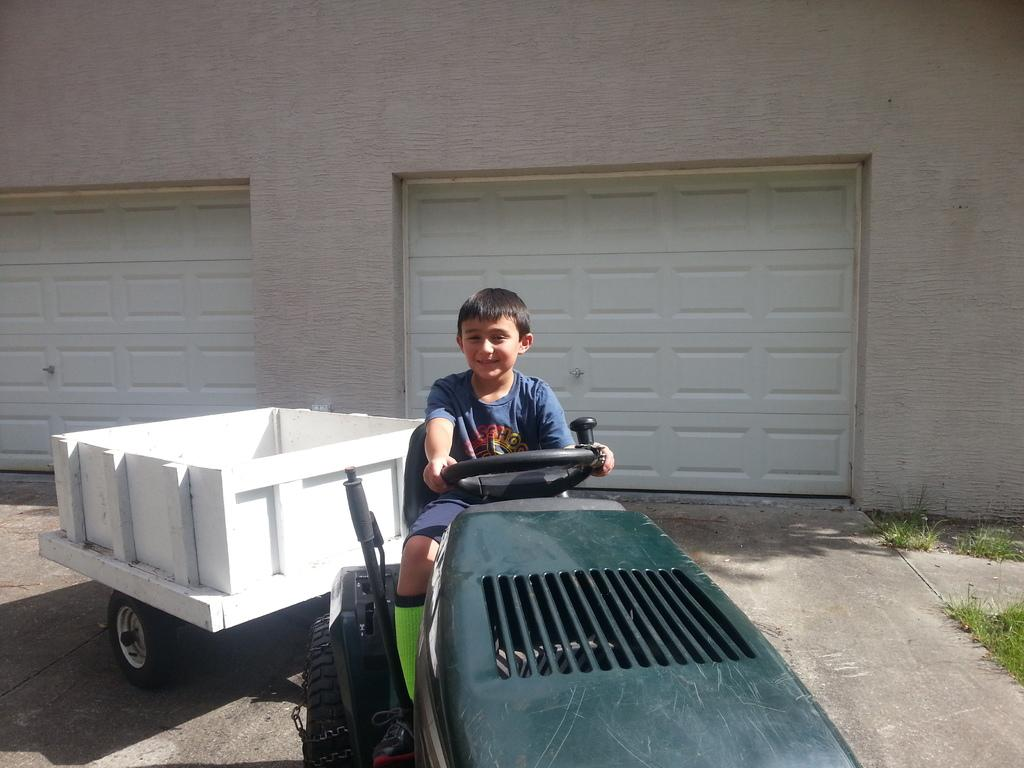What type of vehicle is in the picture? There is a vehicle with a trolley in the picture. Who is in the vehicle? A boy is sitting in the vehicle. How does the boy appear in the image? The boy has a smile on his face. What can be seen in the background of the image? There are wooden doors in the background of the image. What type of stew is being cooked in the vehicle? There is no indication of any cooking or stew in the image; it features a vehicle with a trolley and a smiling boy. Can you describe the man standing next to the wooden doors? There is no man present in the image; it only shows a vehicle with a trolley, a boy, and wooden doors in the background. 